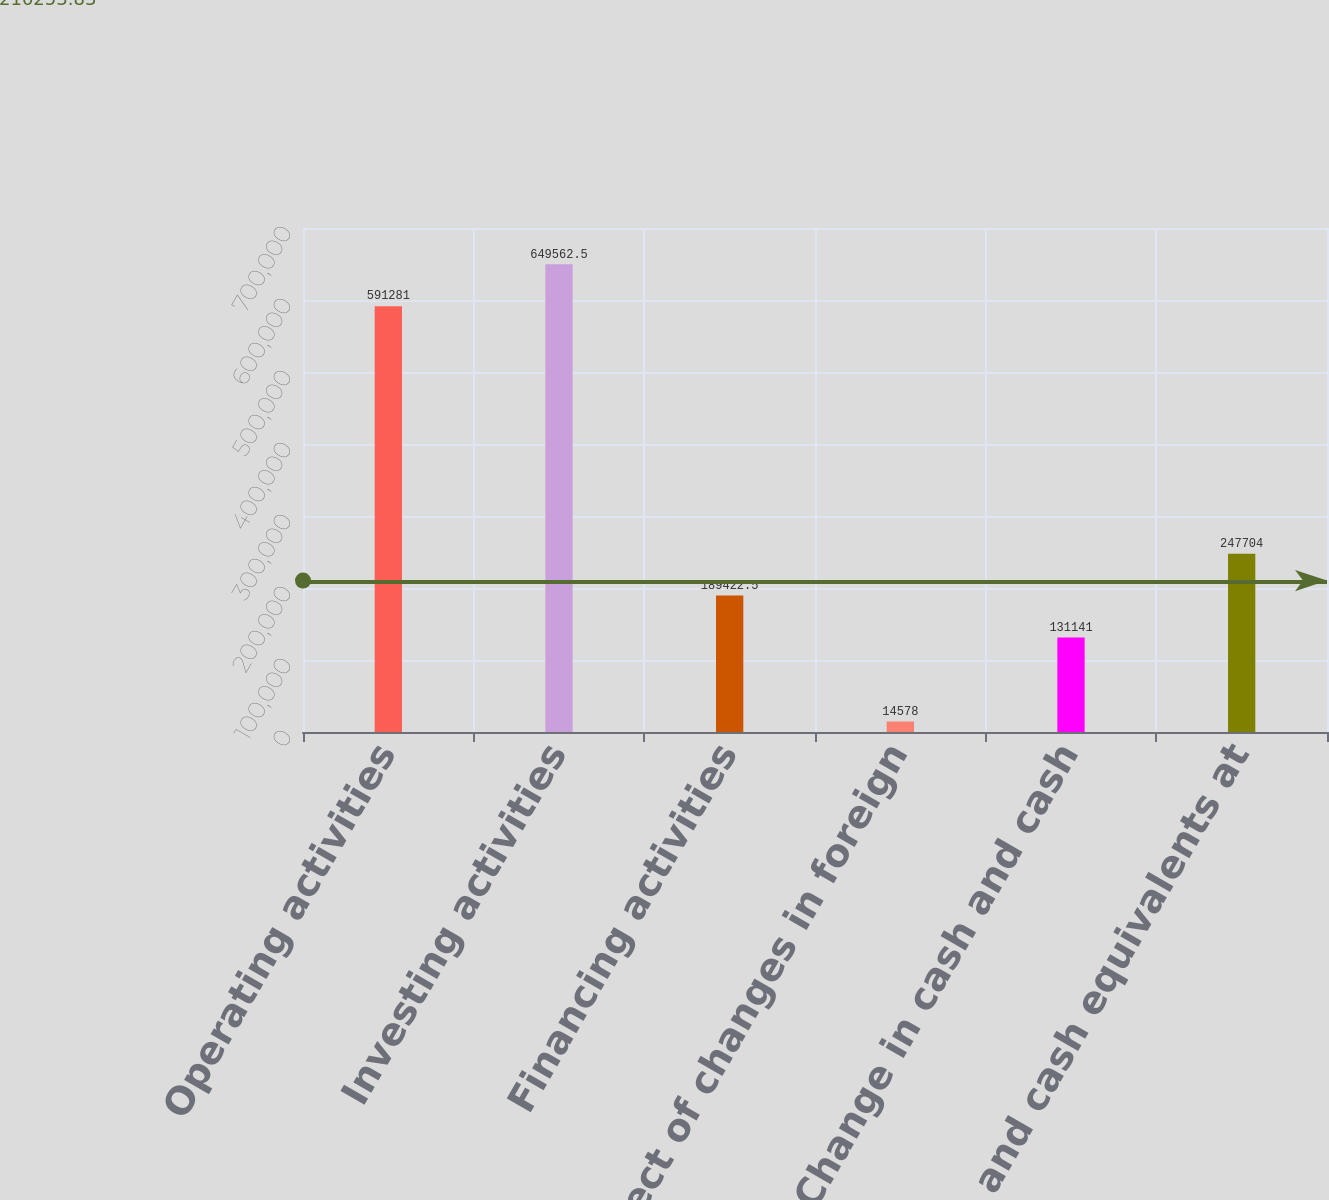Convert chart. <chart><loc_0><loc_0><loc_500><loc_500><bar_chart><fcel>Operating activities<fcel>Investing activities<fcel>Financing activities<fcel>Effect of changes in foreign<fcel>Change in cash and cash<fcel>Cash and cash equivalents at<nl><fcel>591281<fcel>649562<fcel>189422<fcel>14578<fcel>131141<fcel>247704<nl></chart> 